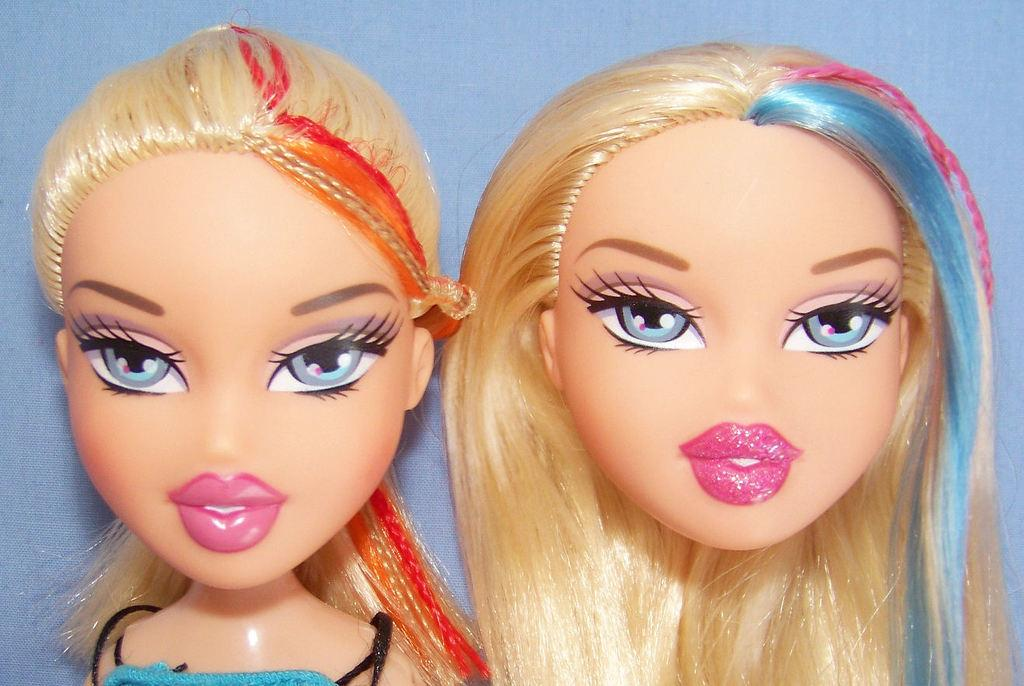How many Barbie dolls are visible in the image? There are two Barbie dolls in the image. Where are the Barbie dolls located in the image? The Barbie dolls are present over a place. What type of flesh can be seen on the Barbie dolls in the image? Barbie dolls are made of plastic and do not have flesh, so this detail cannot be observed in the image. 